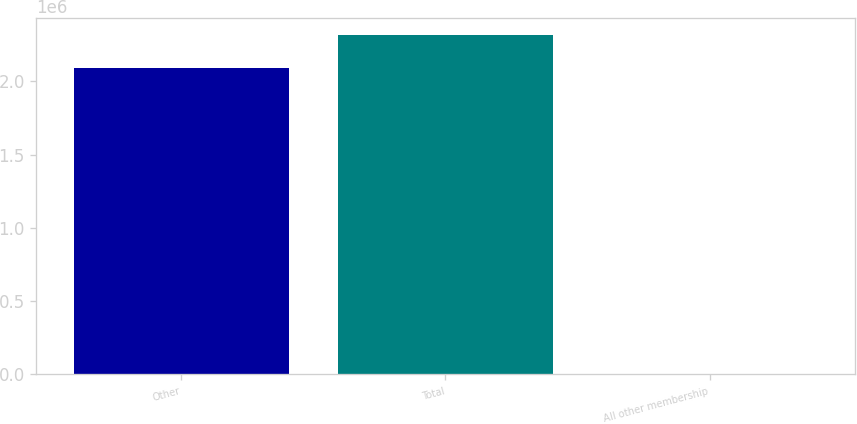Convert chart. <chart><loc_0><loc_0><loc_500><loc_500><bar_chart><fcel>Other<fcel>Total<fcel>All other membership<nl><fcel>2.0919e+06<fcel>2.32054e+06<fcel>91.4<nl></chart> 